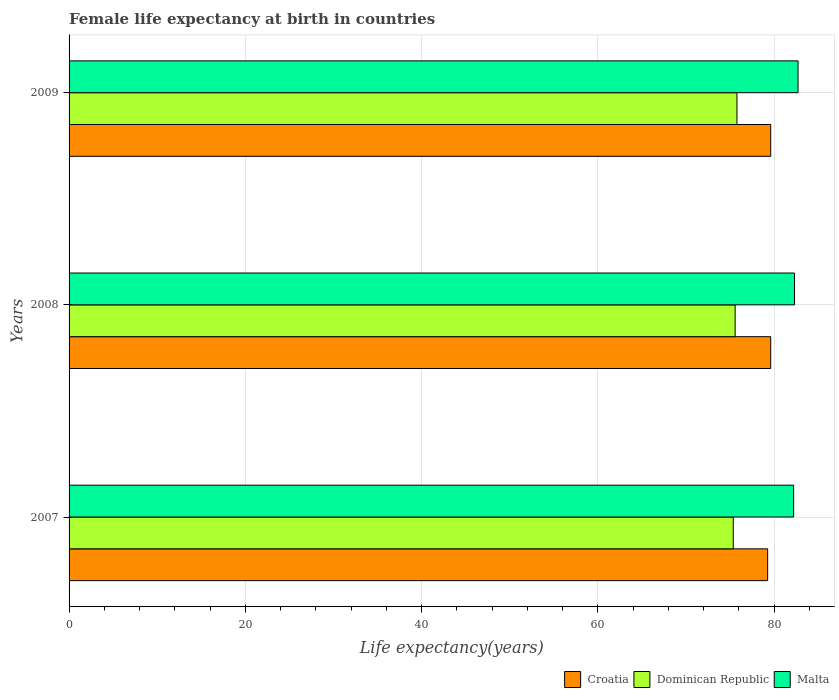How many bars are there on the 2nd tick from the bottom?
Make the answer very short. 3. What is the female life expectancy at birth in Dominican Republic in 2007?
Provide a succinct answer. 75.35. Across all years, what is the maximum female life expectancy at birth in Croatia?
Your answer should be very brief. 79.6. Across all years, what is the minimum female life expectancy at birth in Malta?
Offer a terse response. 82.2. In which year was the female life expectancy at birth in Croatia maximum?
Provide a succinct answer. 2008. What is the total female life expectancy at birth in Croatia in the graph?
Keep it short and to the point. 238.45. What is the difference between the female life expectancy at birth in Dominican Republic in 2007 and that in 2008?
Your response must be concise. -0.21. What is the difference between the female life expectancy at birth in Dominican Republic in 2009 and the female life expectancy at birth in Malta in 2008?
Give a very brief answer. -6.53. What is the average female life expectancy at birth in Croatia per year?
Give a very brief answer. 79.48. In the year 2008, what is the difference between the female life expectancy at birth in Dominican Republic and female life expectancy at birth in Malta?
Make the answer very short. -6.74. What is the ratio of the female life expectancy at birth in Croatia in 2007 to that in 2009?
Make the answer very short. 1. What is the difference between the highest and the second highest female life expectancy at birth in Croatia?
Your response must be concise. 0. In how many years, is the female life expectancy at birth in Dominican Republic greater than the average female life expectancy at birth in Dominican Republic taken over all years?
Provide a succinct answer. 2. Is the sum of the female life expectancy at birth in Dominican Republic in 2007 and 2009 greater than the maximum female life expectancy at birth in Malta across all years?
Your answer should be compact. Yes. What does the 2nd bar from the top in 2007 represents?
Your response must be concise. Dominican Republic. What does the 3rd bar from the bottom in 2007 represents?
Ensure brevity in your answer.  Malta. Does the graph contain any zero values?
Provide a short and direct response. No. Where does the legend appear in the graph?
Provide a succinct answer. Bottom right. How are the legend labels stacked?
Your answer should be compact. Horizontal. What is the title of the graph?
Give a very brief answer. Female life expectancy at birth in countries. What is the label or title of the X-axis?
Keep it short and to the point. Life expectancy(years). What is the label or title of the Y-axis?
Your answer should be very brief. Years. What is the Life expectancy(years) in Croatia in 2007?
Keep it short and to the point. 79.25. What is the Life expectancy(years) in Dominican Republic in 2007?
Give a very brief answer. 75.35. What is the Life expectancy(years) of Malta in 2007?
Your answer should be compact. 82.2. What is the Life expectancy(years) of Croatia in 2008?
Your response must be concise. 79.6. What is the Life expectancy(years) of Dominican Republic in 2008?
Make the answer very short. 75.56. What is the Life expectancy(years) of Malta in 2008?
Provide a short and direct response. 82.3. What is the Life expectancy(years) of Croatia in 2009?
Ensure brevity in your answer.  79.6. What is the Life expectancy(years) of Dominican Republic in 2009?
Your response must be concise. 75.77. What is the Life expectancy(years) in Malta in 2009?
Make the answer very short. 82.7. Across all years, what is the maximum Life expectancy(years) of Croatia?
Your answer should be very brief. 79.6. Across all years, what is the maximum Life expectancy(years) in Dominican Republic?
Offer a terse response. 75.77. Across all years, what is the maximum Life expectancy(years) in Malta?
Make the answer very short. 82.7. Across all years, what is the minimum Life expectancy(years) in Croatia?
Offer a terse response. 79.25. Across all years, what is the minimum Life expectancy(years) in Dominican Republic?
Offer a terse response. 75.35. Across all years, what is the minimum Life expectancy(years) of Malta?
Provide a succinct answer. 82.2. What is the total Life expectancy(years) of Croatia in the graph?
Your answer should be compact. 238.45. What is the total Life expectancy(years) of Dominican Republic in the graph?
Provide a short and direct response. 226.68. What is the total Life expectancy(years) in Malta in the graph?
Give a very brief answer. 247.2. What is the difference between the Life expectancy(years) of Croatia in 2007 and that in 2008?
Keep it short and to the point. -0.35. What is the difference between the Life expectancy(years) in Dominican Republic in 2007 and that in 2008?
Make the answer very short. -0.21. What is the difference between the Life expectancy(years) of Malta in 2007 and that in 2008?
Your response must be concise. -0.1. What is the difference between the Life expectancy(years) of Croatia in 2007 and that in 2009?
Offer a very short reply. -0.35. What is the difference between the Life expectancy(years) of Dominican Republic in 2007 and that in 2009?
Your response must be concise. -0.42. What is the difference between the Life expectancy(years) of Malta in 2007 and that in 2009?
Offer a very short reply. -0.5. What is the difference between the Life expectancy(years) in Croatia in 2008 and that in 2009?
Your answer should be compact. 0. What is the difference between the Life expectancy(years) of Dominican Republic in 2008 and that in 2009?
Keep it short and to the point. -0.21. What is the difference between the Life expectancy(years) of Malta in 2008 and that in 2009?
Your response must be concise. -0.4. What is the difference between the Life expectancy(years) of Croatia in 2007 and the Life expectancy(years) of Dominican Republic in 2008?
Your answer should be compact. 3.69. What is the difference between the Life expectancy(years) of Croatia in 2007 and the Life expectancy(years) of Malta in 2008?
Offer a terse response. -3.05. What is the difference between the Life expectancy(years) in Dominican Republic in 2007 and the Life expectancy(years) in Malta in 2008?
Your answer should be compact. -6.95. What is the difference between the Life expectancy(years) in Croatia in 2007 and the Life expectancy(years) in Dominican Republic in 2009?
Your answer should be compact. 3.48. What is the difference between the Life expectancy(years) of Croatia in 2007 and the Life expectancy(years) of Malta in 2009?
Offer a terse response. -3.45. What is the difference between the Life expectancy(years) of Dominican Republic in 2007 and the Life expectancy(years) of Malta in 2009?
Your response must be concise. -7.35. What is the difference between the Life expectancy(years) in Croatia in 2008 and the Life expectancy(years) in Dominican Republic in 2009?
Your response must be concise. 3.83. What is the difference between the Life expectancy(years) of Dominican Republic in 2008 and the Life expectancy(years) of Malta in 2009?
Keep it short and to the point. -7.14. What is the average Life expectancy(years) of Croatia per year?
Your answer should be compact. 79.48. What is the average Life expectancy(years) of Dominican Republic per year?
Make the answer very short. 75.56. What is the average Life expectancy(years) of Malta per year?
Provide a short and direct response. 82.4. In the year 2007, what is the difference between the Life expectancy(years) in Croatia and Life expectancy(years) in Dominican Republic?
Provide a succinct answer. 3.9. In the year 2007, what is the difference between the Life expectancy(years) of Croatia and Life expectancy(years) of Malta?
Provide a succinct answer. -2.95. In the year 2007, what is the difference between the Life expectancy(years) of Dominican Republic and Life expectancy(years) of Malta?
Keep it short and to the point. -6.85. In the year 2008, what is the difference between the Life expectancy(years) of Croatia and Life expectancy(years) of Dominican Republic?
Your answer should be compact. 4.04. In the year 2008, what is the difference between the Life expectancy(years) of Croatia and Life expectancy(years) of Malta?
Ensure brevity in your answer.  -2.7. In the year 2008, what is the difference between the Life expectancy(years) of Dominican Republic and Life expectancy(years) of Malta?
Offer a terse response. -6.74. In the year 2009, what is the difference between the Life expectancy(years) of Croatia and Life expectancy(years) of Dominican Republic?
Make the answer very short. 3.83. In the year 2009, what is the difference between the Life expectancy(years) in Croatia and Life expectancy(years) in Malta?
Your response must be concise. -3.1. In the year 2009, what is the difference between the Life expectancy(years) in Dominican Republic and Life expectancy(years) in Malta?
Provide a short and direct response. -6.93. What is the ratio of the Life expectancy(years) in Croatia in 2008 to that in 2009?
Make the answer very short. 1. What is the ratio of the Life expectancy(years) of Dominican Republic in 2008 to that in 2009?
Your answer should be compact. 1. What is the difference between the highest and the second highest Life expectancy(years) in Dominican Republic?
Ensure brevity in your answer.  0.21. What is the difference between the highest and the second highest Life expectancy(years) in Malta?
Keep it short and to the point. 0.4. What is the difference between the highest and the lowest Life expectancy(years) in Croatia?
Your response must be concise. 0.35. What is the difference between the highest and the lowest Life expectancy(years) in Dominican Republic?
Your answer should be compact. 0.42. What is the difference between the highest and the lowest Life expectancy(years) of Malta?
Provide a short and direct response. 0.5. 